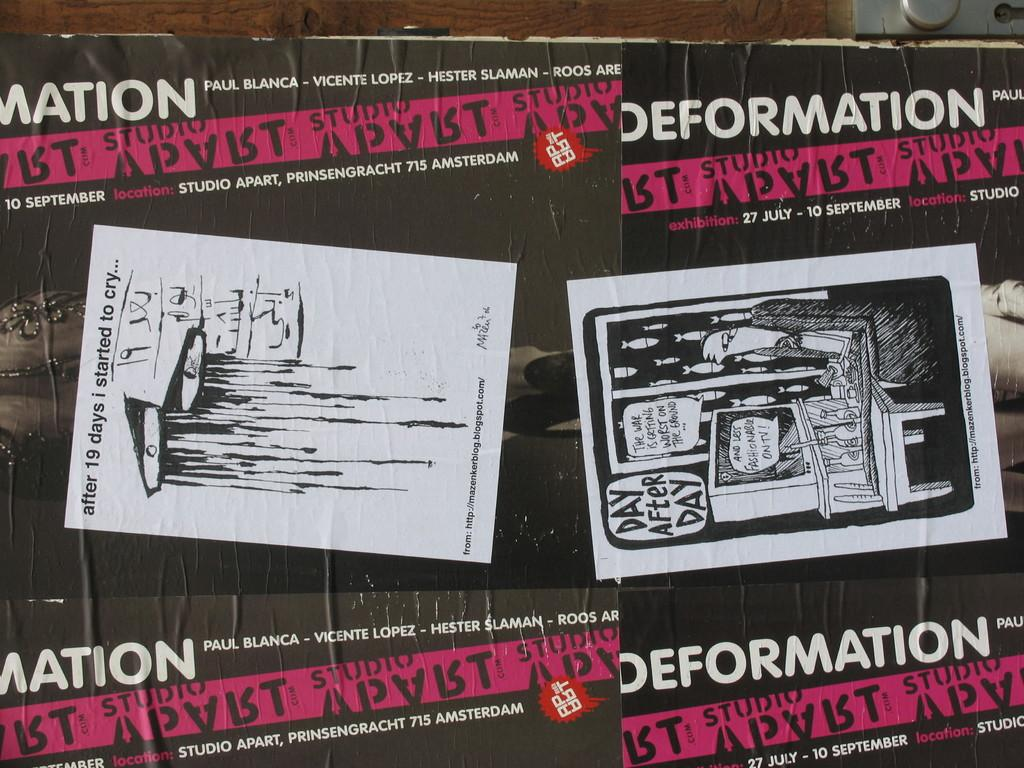Provide a one-sentence caption for the provided image. Poster advertising Defamation art event for September 10th. 